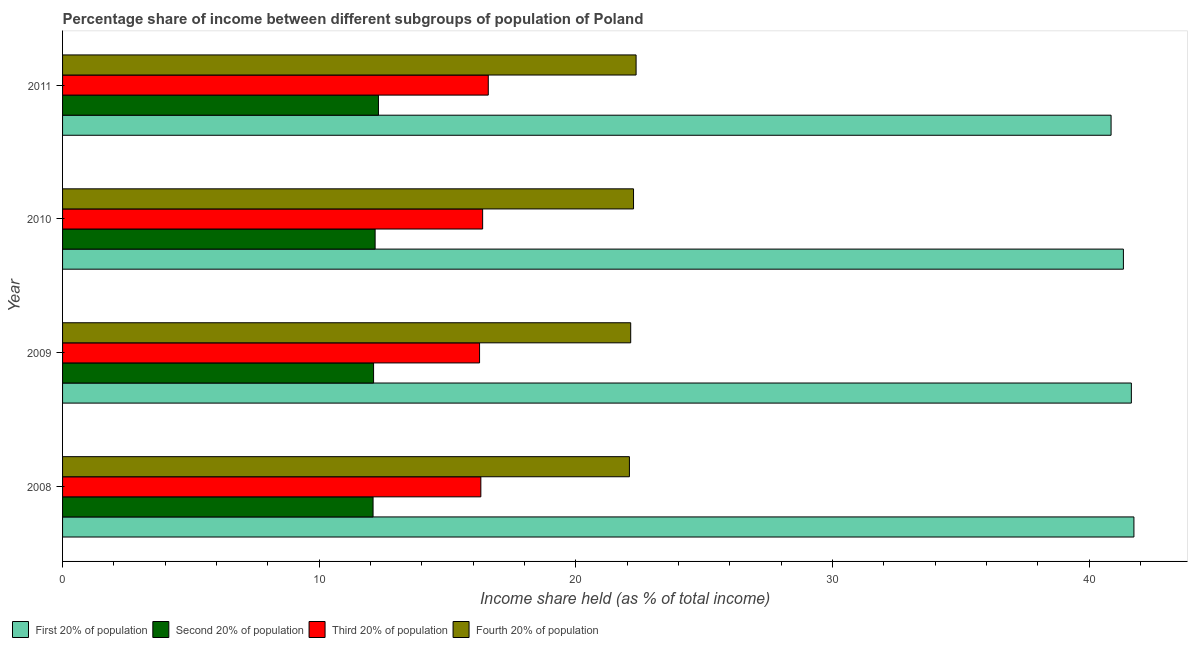How many different coloured bars are there?
Your answer should be compact. 4. How many groups of bars are there?
Give a very brief answer. 4. Are the number of bars on each tick of the Y-axis equal?
Ensure brevity in your answer.  Yes. How many bars are there on the 2nd tick from the bottom?
Provide a succinct answer. 4. In how many cases, is the number of bars for a given year not equal to the number of legend labels?
Your response must be concise. 0. What is the share of the income held by fourth 20% of the population in 2010?
Your answer should be compact. 22.25. Across all years, what is the maximum share of the income held by second 20% of the population?
Offer a very short reply. 12.31. Across all years, what is the minimum share of the income held by third 20% of the population?
Your response must be concise. 16.25. In which year was the share of the income held by third 20% of the population maximum?
Offer a terse response. 2011. What is the total share of the income held by fourth 20% of the population in the graph?
Keep it short and to the point. 88.83. What is the difference between the share of the income held by first 20% of the population in 2009 and that in 2010?
Give a very brief answer. 0.31. What is the difference between the share of the income held by second 20% of the population in 2010 and the share of the income held by first 20% of the population in 2011?
Offer a very short reply. -28.68. What is the average share of the income held by first 20% of the population per year?
Provide a short and direct response. 41.4. In the year 2011, what is the difference between the share of the income held by third 20% of the population and share of the income held by first 20% of the population?
Give a very brief answer. -24.27. In how many years, is the share of the income held by first 20% of the population greater than 40 %?
Give a very brief answer. 4. Is the difference between the share of the income held by third 20% of the population in 2009 and 2010 greater than the difference between the share of the income held by first 20% of the population in 2009 and 2010?
Your answer should be compact. No. What is the difference between the highest and the second highest share of the income held by second 20% of the population?
Offer a very short reply. 0.13. What is the difference between the highest and the lowest share of the income held by first 20% of the population?
Your response must be concise. 0.89. Is the sum of the share of the income held by fourth 20% of the population in 2008 and 2011 greater than the maximum share of the income held by third 20% of the population across all years?
Make the answer very short. Yes. What does the 1st bar from the top in 2008 represents?
Make the answer very short. Fourth 20% of population. What does the 1st bar from the bottom in 2009 represents?
Provide a succinct answer. First 20% of population. Is it the case that in every year, the sum of the share of the income held by first 20% of the population and share of the income held by second 20% of the population is greater than the share of the income held by third 20% of the population?
Make the answer very short. Yes. How many bars are there?
Make the answer very short. 16. What is the difference between two consecutive major ticks on the X-axis?
Your response must be concise. 10. Are the values on the major ticks of X-axis written in scientific E-notation?
Provide a succinct answer. No. Does the graph contain grids?
Keep it short and to the point. No. Where does the legend appear in the graph?
Your answer should be compact. Bottom left. What is the title of the graph?
Make the answer very short. Percentage share of income between different subgroups of population of Poland. Does "Building human resources" appear as one of the legend labels in the graph?
Offer a very short reply. No. What is the label or title of the X-axis?
Make the answer very short. Income share held (as % of total income). What is the label or title of the Y-axis?
Make the answer very short. Year. What is the Income share held (as % of total income) in First 20% of population in 2008?
Your response must be concise. 41.75. What is the Income share held (as % of total income) of Second 20% of population in 2008?
Provide a short and direct response. 12.1. What is the Income share held (as % of total income) of Fourth 20% of population in 2008?
Your response must be concise. 22.09. What is the Income share held (as % of total income) of First 20% of population in 2009?
Make the answer very short. 41.65. What is the Income share held (as % of total income) in Second 20% of population in 2009?
Give a very brief answer. 12.12. What is the Income share held (as % of total income) in Third 20% of population in 2009?
Ensure brevity in your answer.  16.25. What is the Income share held (as % of total income) of Fourth 20% of population in 2009?
Make the answer very short. 22.14. What is the Income share held (as % of total income) in First 20% of population in 2010?
Make the answer very short. 41.34. What is the Income share held (as % of total income) of Second 20% of population in 2010?
Make the answer very short. 12.18. What is the Income share held (as % of total income) in Third 20% of population in 2010?
Give a very brief answer. 16.37. What is the Income share held (as % of total income) of Fourth 20% of population in 2010?
Your answer should be very brief. 22.25. What is the Income share held (as % of total income) in First 20% of population in 2011?
Your answer should be very brief. 40.86. What is the Income share held (as % of total income) in Second 20% of population in 2011?
Ensure brevity in your answer.  12.31. What is the Income share held (as % of total income) in Third 20% of population in 2011?
Provide a short and direct response. 16.59. What is the Income share held (as % of total income) in Fourth 20% of population in 2011?
Offer a very short reply. 22.35. Across all years, what is the maximum Income share held (as % of total income) of First 20% of population?
Offer a very short reply. 41.75. Across all years, what is the maximum Income share held (as % of total income) of Second 20% of population?
Your answer should be compact. 12.31. Across all years, what is the maximum Income share held (as % of total income) of Third 20% of population?
Your answer should be very brief. 16.59. Across all years, what is the maximum Income share held (as % of total income) in Fourth 20% of population?
Your response must be concise. 22.35. Across all years, what is the minimum Income share held (as % of total income) in First 20% of population?
Make the answer very short. 40.86. Across all years, what is the minimum Income share held (as % of total income) of Second 20% of population?
Give a very brief answer. 12.1. Across all years, what is the minimum Income share held (as % of total income) of Third 20% of population?
Offer a very short reply. 16.25. Across all years, what is the minimum Income share held (as % of total income) in Fourth 20% of population?
Make the answer very short. 22.09. What is the total Income share held (as % of total income) in First 20% of population in the graph?
Offer a terse response. 165.6. What is the total Income share held (as % of total income) of Second 20% of population in the graph?
Provide a succinct answer. 48.71. What is the total Income share held (as % of total income) in Third 20% of population in the graph?
Give a very brief answer. 65.51. What is the total Income share held (as % of total income) of Fourth 20% of population in the graph?
Offer a terse response. 88.83. What is the difference between the Income share held (as % of total income) of First 20% of population in 2008 and that in 2009?
Provide a short and direct response. 0.1. What is the difference between the Income share held (as % of total income) of Second 20% of population in 2008 and that in 2009?
Keep it short and to the point. -0.02. What is the difference between the Income share held (as % of total income) of Fourth 20% of population in 2008 and that in 2009?
Provide a short and direct response. -0.05. What is the difference between the Income share held (as % of total income) in First 20% of population in 2008 and that in 2010?
Give a very brief answer. 0.41. What is the difference between the Income share held (as % of total income) in Second 20% of population in 2008 and that in 2010?
Provide a short and direct response. -0.08. What is the difference between the Income share held (as % of total income) in Third 20% of population in 2008 and that in 2010?
Provide a short and direct response. -0.07. What is the difference between the Income share held (as % of total income) in Fourth 20% of population in 2008 and that in 2010?
Your answer should be very brief. -0.16. What is the difference between the Income share held (as % of total income) of First 20% of population in 2008 and that in 2011?
Your response must be concise. 0.89. What is the difference between the Income share held (as % of total income) in Second 20% of population in 2008 and that in 2011?
Your answer should be very brief. -0.21. What is the difference between the Income share held (as % of total income) in Third 20% of population in 2008 and that in 2011?
Make the answer very short. -0.29. What is the difference between the Income share held (as % of total income) of Fourth 20% of population in 2008 and that in 2011?
Make the answer very short. -0.26. What is the difference between the Income share held (as % of total income) in First 20% of population in 2009 and that in 2010?
Provide a succinct answer. 0.31. What is the difference between the Income share held (as % of total income) in Second 20% of population in 2009 and that in 2010?
Make the answer very short. -0.06. What is the difference between the Income share held (as % of total income) in Third 20% of population in 2009 and that in 2010?
Keep it short and to the point. -0.12. What is the difference between the Income share held (as % of total income) in Fourth 20% of population in 2009 and that in 2010?
Keep it short and to the point. -0.11. What is the difference between the Income share held (as % of total income) in First 20% of population in 2009 and that in 2011?
Provide a succinct answer. 0.79. What is the difference between the Income share held (as % of total income) in Second 20% of population in 2009 and that in 2011?
Offer a very short reply. -0.19. What is the difference between the Income share held (as % of total income) of Third 20% of population in 2009 and that in 2011?
Ensure brevity in your answer.  -0.34. What is the difference between the Income share held (as % of total income) of Fourth 20% of population in 2009 and that in 2011?
Offer a terse response. -0.21. What is the difference between the Income share held (as % of total income) of First 20% of population in 2010 and that in 2011?
Your answer should be compact. 0.48. What is the difference between the Income share held (as % of total income) in Second 20% of population in 2010 and that in 2011?
Keep it short and to the point. -0.13. What is the difference between the Income share held (as % of total income) in Third 20% of population in 2010 and that in 2011?
Your answer should be compact. -0.22. What is the difference between the Income share held (as % of total income) in First 20% of population in 2008 and the Income share held (as % of total income) in Second 20% of population in 2009?
Provide a short and direct response. 29.63. What is the difference between the Income share held (as % of total income) of First 20% of population in 2008 and the Income share held (as % of total income) of Third 20% of population in 2009?
Your response must be concise. 25.5. What is the difference between the Income share held (as % of total income) in First 20% of population in 2008 and the Income share held (as % of total income) in Fourth 20% of population in 2009?
Your response must be concise. 19.61. What is the difference between the Income share held (as % of total income) of Second 20% of population in 2008 and the Income share held (as % of total income) of Third 20% of population in 2009?
Your response must be concise. -4.15. What is the difference between the Income share held (as % of total income) in Second 20% of population in 2008 and the Income share held (as % of total income) in Fourth 20% of population in 2009?
Offer a terse response. -10.04. What is the difference between the Income share held (as % of total income) in Third 20% of population in 2008 and the Income share held (as % of total income) in Fourth 20% of population in 2009?
Your answer should be compact. -5.84. What is the difference between the Income share held (as % of total income) of First 20% of population in 2008 and the Income share held (as % of total income) of Second 20% of population in 2010?
Offer a terse response. 29.57. What is the difference between the Income share held (as % of total income) in First 20% of population in 2008 and the Income share held (as % of total income) in Third 20% of population in 2010?
Provide a short and direct response. 25.38. What is the difference between the Income share held (as % of total income) in Second 20% of population in 2008 and the Income share held (as % of total income) in Third 20% of population in 2010?
Give a very brief answer. -4.27. What is the difference between the Income share held (as % of total income) of Second 20% of population in 2008 and the Income share held (as % of total income) of Fourth 20% of population in 2010?
Keep it short and to the point. -10.15. What is the difference between the Income share held (as % of total income) in Third 20% of population in 2008 and the Income share held (as % of total income) in Fourth 20% of population in 2010?
Make the answer very short. -5.95. What is the difference between the Income share held (as % of total income) of First 20% of population in 2008 and the Income share held (as % of total income) of Second 20% of population in 2011?
Ensure brevity in your answer.  29.44. What is the difference between the Income share held (as % of total income) of First 20% of population in 2008 and the Income share held (as % of total income) of Third 20% of population in 2011?
Provide a succinct answer. 25.16. What is the difference between the Income share held (as % of total income) of First 20% of population in 2008 and the Income share held (as % of total income) of Fourth 20% of population in 2011?
Your response must be concise. 19.4. What is the difference between the Income share held (as % of total income) of Second 20% of population in 2008 and the Income share held (as % of total income) of Third 20% of population in 2011?
Offer a terse response. -4.49. What is the difference between the Income share held (as % of total income) in Second 20% of population in 2008 and the Income share held (as % of total income) in Fourth 20% of population in 2011?
Your response must be concise. -10.25. What is the difference between the Income share held (as % of total income) of Third 20% of population in 2008 and the Income share held (as % of total income) of Fourth 20% of population in 2011?
Ensure brevity in your answer.  -6.05. What is the difference between the Income share held (as % of total income) in First 20% of population in 2009 and the Income share held (as % of total income) in Second 20% of population in 2010?
Your answer should be very brief. 29.47. What is the difference between the Income share held (as % of total income) in First 20% of population in 2009 and the Income share held (as % of total income) in Third 20% of population in 2010?
Make the answer very short. 25.28. What is the difference between the Income share held (as % of total income) in Second 20% of population in 2009 and the Income share held (as % of total income) in Third 20% of population in 2010?
Your answer should be very brief. -4.25. What is the difference between the Income share held (as % of total income) in Second 20% of population in 2009 and the Income share held (as % of total income) in Fourth 20% of population in 2010?
Make the answer very short. -10.13. What is the difference between the Income share held (as % of total income) in Third 20% of population in 2009 and the Income share held (as % of total income) in Fourth 20% of population in 2010?
Offer a terse response. -6. What is the difference between the Income share held (as % of total income) in First 20% of population in 2009 and the Income share held (as % of total income) in Second 20% of population in 2011?
Offer a very short reply. 29.34. What is the difference between the Income share held (as % of total income) in First 20% of population in 2009 and the Income share held (as % of total income) in Third 20% of population in 2011?
Your answer should be compact. 25.06. What is the difference between the Income share held (as % of total income) of First 20% of population in 2009 and the Income share held (as % of total income) of Fourth 20% of population in 2011?
Keep it short and to the point. 19.3. What is the difference between the Income share held (as % of total income) in Second 20% of population in 2009 and the Income share held (as % of total income) in Third 20% of population in 2011?
Keep it short and to the point. -4.47. What is the difference between the Income share held (as % of total income) of Second 20% of population in 2009 and the Income share held (as % of total income) of Fourth 20% of population in 2011?
Offer a terse response. -10.23. What is the difference between the Income share held (as % of total income) of First 20% of population in 2010 and the Income share held (as % of total income) of Second 20% of population in 2011?
Offer a terse response. 29.03. What is the difference between the Income share held (as % of total income) in First 20% of population in 2010 and the Income share held (as % of total income) in Third 20% of population in 2011?
Give a very brief answer. 24.75. What is the difference between the Income share held (as % of total income) in First 20% of population in 2010 and the Income share held (as % of total income) in Fourth 20% of population in 2011?
Provide a succinct answer. 18.99. What is the difference between the Income share held (as % of total income) in Second 20% of population in 2010 and the Income share held (as % of total income) in Third 20% of population in 2011?
Keep it short and to the point. -4.41. What is the difference between the Income share held (as % of total income) in Second 20% of population in 2010 and the Income share held (as % of total income) in Fourth 20% of population in 2011?
Your answer should be very brief. -10.17. What is the difference between the Income share held (as % of total income) in Third 20% of population in 2010 and the Income share held (as % of total income) in Fourth 20% of population in 2011?
Provide a short and direct response. -5.98. What is the average Income share held (as % of total income) of First 20% of population per year?
Your answer should be compact. 41.4. What is the average Income share held (as % of total income) of Second 20% of population per year?
Your answer should be compact. 12.18. What is the average Income share held (as % of total income) in Third 20% of population per year?
Provide a succinct answer. 16.38. What is the average Income share held (as % of total income) in Fourth 20% of population per year?
Provide a succinct answer. 22.21. In the year 2008, what is the difference between the Income share held (as % of total income) in First 20% of population and Income share held (as % of total income) in Second 20% of population?
Provide a succinct answer. 29.65. In the year 2008, what is the difference between the Income share held (as % of total income) in First 20% of population and Income share held (as % of total income) in Third 20% of population?
Your answer should be compact. 25.45. In the year 2008, what is the difference between the Income share held (as % of total income) of First 20% of population and Income share held (as % of total income) of Fourth 20% of population?
Provide a short and direct response. 19.66. In the year 2008, what is the difference between the Income share held (as % of total income) in Second 20% of population and Income share held (as % of total income) in Fourth 20% of population?
Provide a succinct answer. -9.99. In the year 2008, what is the difference between the Income share held (as % of total income) of Third 20% of population and Income share held (as % of total income) of Fourth 20% of population?
Provide a short and direct response. -5.79. In the year 2009, what is the difference between the Income share held (as % of total income) in First 20% of population and Income share held (as % of total income) in Second 20% of population?
Provide a succinct answer. 29.53. In the year 2009, what is the difference between the Income share held (as % of total income) in First 20% of population and Income share held (as % of total income) in Third 20% of population?
Make the answer very short. 25.4. In the year 2009, what is the difference between the Income share held (as % of total income) in First 20% of population and Income share held (as % of total income) in Fourth 20% of population?
Your response must be concise. 19.51. In the year 2009, what is the difference between the Income share held (as % of total income) of Second 20% of population and Income share held (as % of total income) of Third 20% of population?
Ensure brevity in your answer.  -4.13. In the year 2009, what is the difference between the Income share held (as % of total income) of Second 20% of population and Income share held (as % of total income) of Fourth 20% of population?
Your answer should be compact. -10.02. In the year 2009, what is the difference between the Income share held (as % of total income) in Third 20% of population and Income share held (as % of total income) in Fourth 20% of population?
Offer a very short reply. -5.89. In the year 2010, what is the difference between the Income share held (as % of total income) in First 20% of population and Income share held (as % of total income) in Second 20% of population?
Ensure brevity in your answer.  29.16. In the year 2010, what is the difference between the Income share held (as % of total income) in First 20% of population and Income share held (as % of total income) in Third 20% of population?
Keep it short and to the point. 24.97. In the year 2010, what is the difference between the Income share held (as % of total income) in First 20% of population and Income share held (as % of total income) in Fourth 20% of population?
Offer a terse response. 19.09. In the year 2010, what is the difference between the Income share held (as % of total income) of Second 20% of population and Income share held (as % of total income) of Third 20% of population?
Make the answer very short. -4.19. In the year 2010, what is the difference between the Income share held (as % of total income) of Second 20% of population and Income share held (as % of total income) of Fourth 20% of population?
Provide a succinct answer. -10.07. In the year 2010, what is the difference between the Income share held (as % of total income) of Third 20% of population and Income share held (as % of total income) of Fourth 20% of population?
Keep it short and to the point. -5.88. In the year 2011, what is the difference between the Income share held (as % of total income) in First 20% of population and Income share held (as % of total income) in Second 20% of population?
Offer a very short reply. 28.55. In the year 2011, what is the difference between the Income share held (as % of total income) of First 20% of population and Income share held (as % of total income) of Third 20% of population?
Give a very brief answer. 24.27. In the year 2011, what is the difference between the Income share held (as % of total income) of First 20% of population and Income share held (as % of total income) of Fourth 20% of population?
Make the answer very short. 18.51. In the year 2011, what is the difference between the Income share held (as % of total income) of Second 20% of population and Income share held (as % of total income) of Third 20% of population?
Give a very brief answer. -4.28. In the year 2011, what is the difference between the Income share held (as % of total income) in Second 20% of population and Income share held (as % of total income) in Fourth 20% of population?
Provide a succinct answer. -10.04. In the year 2011, what is the difference between the Income share held (as % of total income) in Third 20% of population and Income share held (as % of total income) in Fourth 20% of population?
Keep it short and to the point. -5.76. What is the ratio of the Income share held (as % of total income) in First 20% of population in 2008 to that in 2009?
Make the answer very short. 1. What is the ratio of the Income share held (as % of total income) in Fourth 20% of population in 2008 to that in 2009?
Your answer should be compact. 1. What is the ratio of the Income share held (as % of total income) in First 20% of population in 2008 to that in 2010?
Offer a very short reply. 1.01. What is the ratio of the Income share held (as % of total income) in Fourth 20% of population in 2008 to that in 2010?
Your answer should be compact. 0.99. What is the ratio of the Income share held (as % of total income) in First 20% of population in 2008 to that in 2011?
Offer a terse response. 1.02. What is the ratio of the Income share held (as % of total income) of Second 20% of population in 2008 to that in 2011?
Offer a terse response. 0.98. What is the ratio of the Income share held (as % of total income) in Third 20% of population in 2008 to that in 2011?
Provide a succinct answer. 0.98. What is the ratio of the Income share held (as % of total income) of Fourth 20% of population in 2008 to that in 2011?
Offer a terse response. 0.99. What is the ratio of the Income share held (as % of total income) in First 20% of population in 2009 to that in 2010?
Make the answer very short. 1.01. What is the ratio of the Income share held (as % of total income) in Third 20% of population in 2009 to that in 2010?
Your answer should be compact. 0.99. What is the ratio of the Income share held (as % of total income) of First 20% of population in 2009 to that in 2011?
Ensure brevity in your answer.  1.02. What is the ratio of the Income share held (as % of total income) in Second 20% of population in 2009 to that in 2011?
Give a very brief answer. 0.98. What is the ratio of the Income share held (as % of total income) in Third 20% of population in 2009 to that in 2011?
Keep it short and to the point. 0.98. What is the ratio of the Income share held (as % of total income) of Fourth 20% of population in 2009 to that in 2011?
Your response must be concise. 0.99. What is the ratio of the Income share held (as % of total income) in First 20% of population in 2010 to that in 2011?
Ensure brevity in your answer.  1.01. What is the ratio of the Income share held (as % of total income) of Third 20% of population in 2010 to that in 2011?
Make the answer very short. 0.99. What is the difference between the highest and the second highest Income share held (as % of total income) of First 20% of population?
Offer a very short reply. 0.1. What is the difference between the highest and the second highest Income share held (as % of total income) in Second 20% of population?
Offer a terse response. 0.13. What is the difference between the highest and the second highest Income share held (as % of total income) in Third 20% of population?
Provide a short and direct response. 0.22. What is the difference between the highest and the lowest Income share held (as % of total income) of First 20% of population?
Keep it short and to the point. 0.89. What is the difference between the highest and the lowest Income share held (as % of total income) in Second 20% of population?
Give a very brief answer. 0.21. What is the difference between the highest and the lowest Income share held (as % of total income) of Third 20% of population?
Your answer should be very brief. 0.34. What is the difference between the highest and the lowest Income share held (as % of total income) of Fourth 20% of population?
Your answer should be compact. 0.26. 